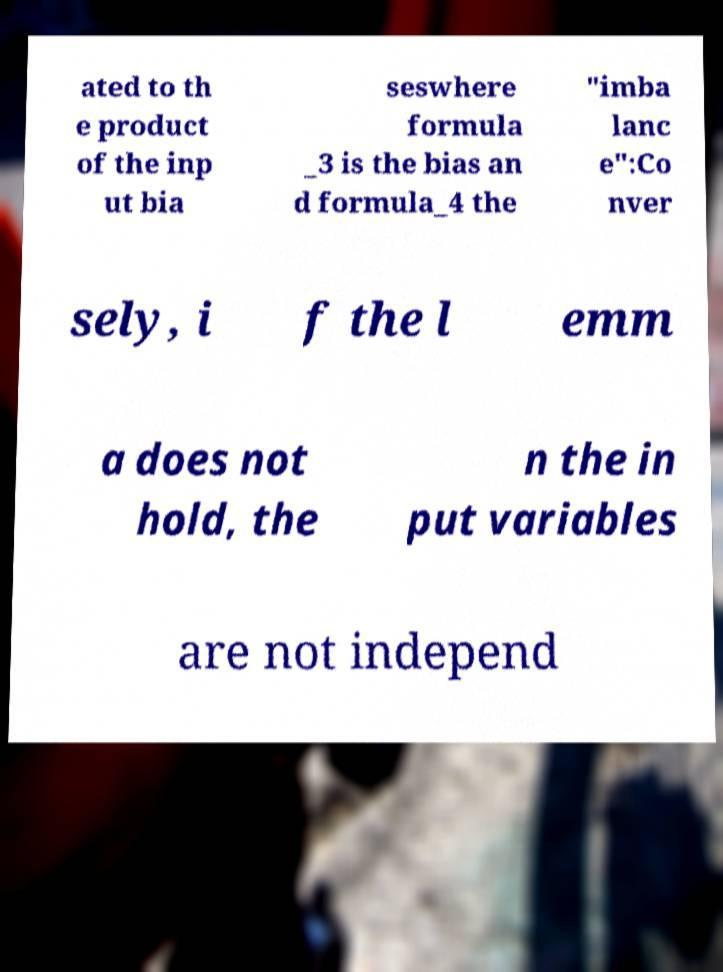Can you read and provide the text displayed in the image?This photo seems to have some interesting text. Can you extract and type it out for me? ated to th e product of the inp ut bia seswhere formula _3 is the bias an d formula_4 the "imba lanc e":Co nver sely, i f the l emm a does not hold, the n the in put variables are not independ 